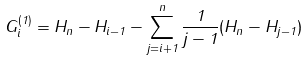Convert formula to latex. <formula><loc_0><loc_0><loc_500><loc_500>G _ { i } ^ { ( 1 ) } = H _ { n } - H _ { i - 1 } - \sum _ { j = i + 1 } ^ { n } \frac { 1 } { j - 1 } ( H _ { n } - H _ { j - 1 } )</formula> 